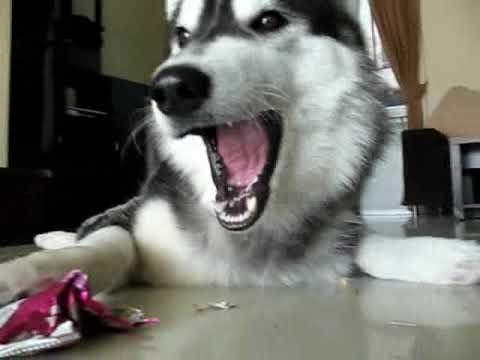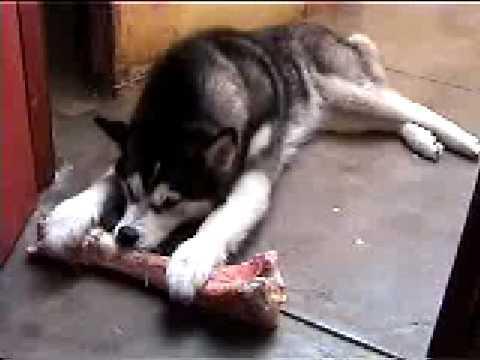The first image is the image on the left, the second image is the image on the right. Considering the images on both sides, is "A dog can be seen interacting with a severed limb portion of another animal." valid? Answer yes or no. Yes. The first image is the image on the left, the second image is the image on the right. For the images shown, is this caption "Each image shows a single husky dog, and one of the dogs pictured is in a reclining pose with its muzzle over a pinkish 'bone' and at least one paw near the object." true? Answer yes or no. Yes. 